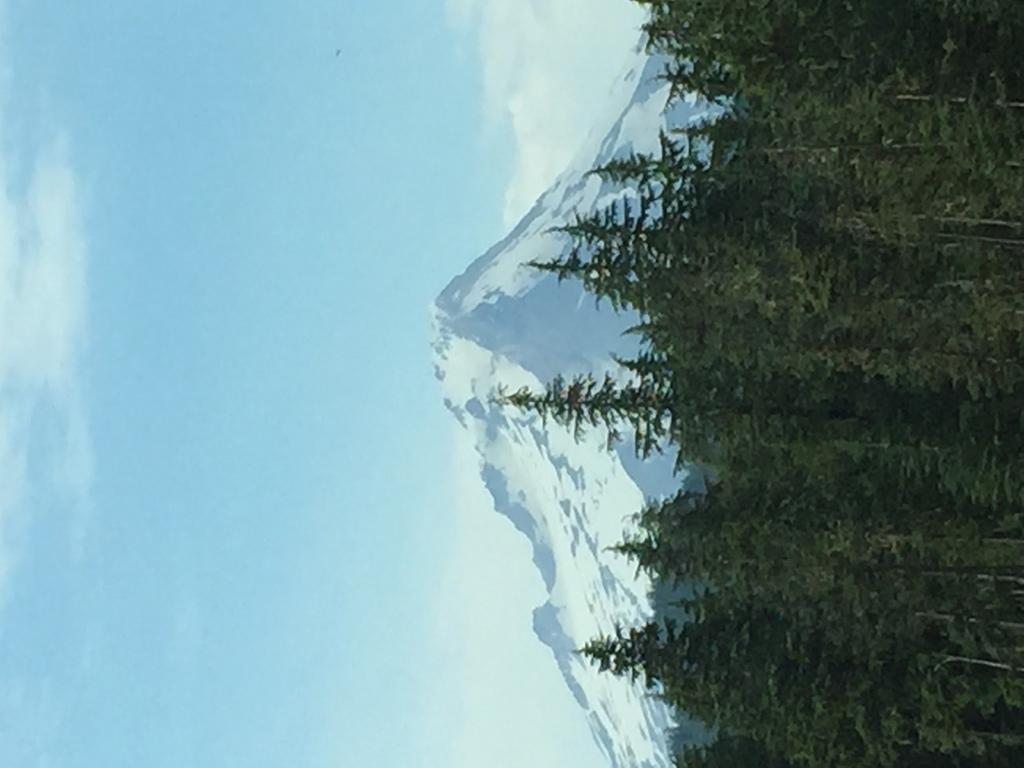How is the picture in the image oriented? The picture in the image is right rotated. What type of vegetation can be seen in the image? There are trees in the image, which are green in color. What geographical feature is present in the image? There is a mountain in the image with some snow on it. What can be seen in the background of the image? The sky is visible in the background of the image. Where is the bomb hidden in the image? There is no bomb present in the image. What type of toad can be seen hopping on the mountain in the image? There is no toad present in the image; it only features a mountain with snow. 